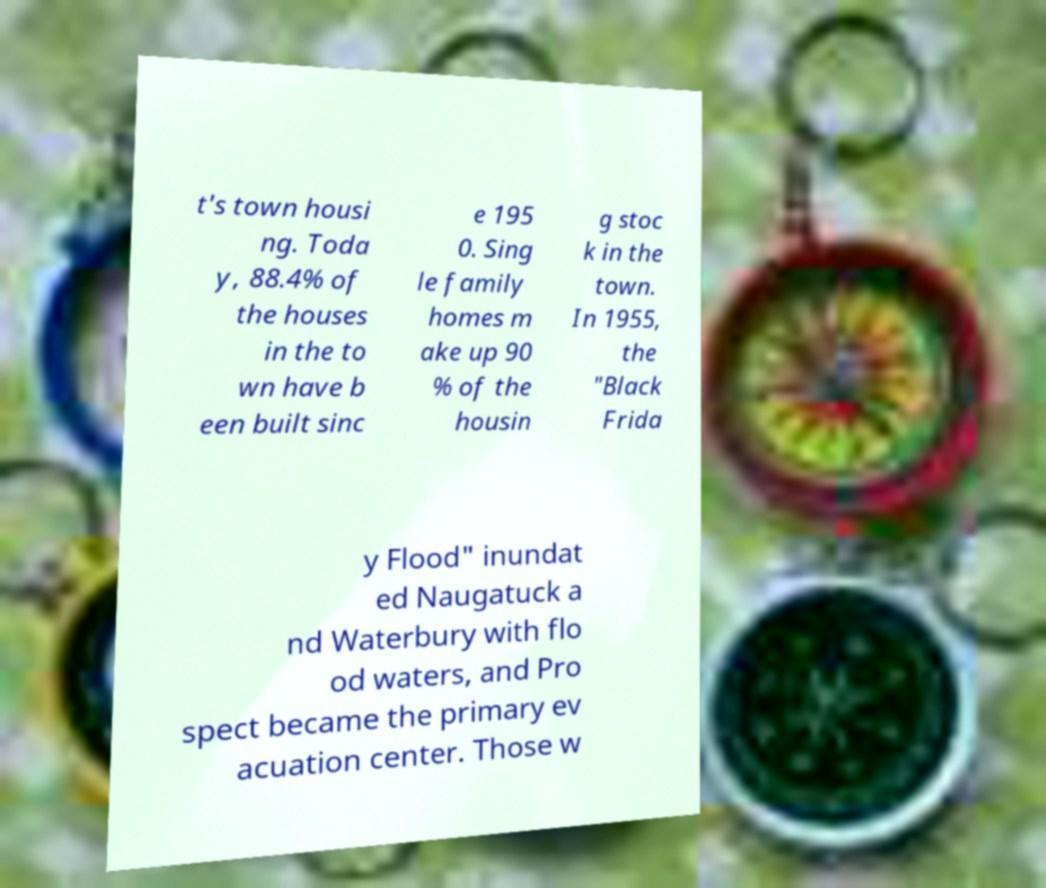Can you read and provide the text displayed in the image?This photo seems to have some interesting text. Can you extract and type it out for me? t's town housi ng. Toda y, 88.4% of the houses in the to wn have b een built sinc e 195 0. Sing le family homes m ake up 90 % of the housin g stoc k in the town. In 1955, the "Black Frida y Flood" inundat ed Naugatuck a nd Waterbury with flo od waters, and Pro spect became the primary ev acuation center. Those w 